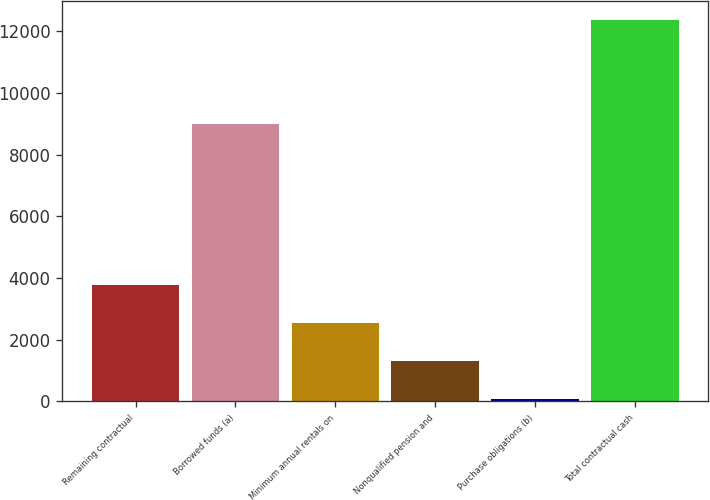Convert chart to OTSL. <chart><loc_0><loc_0><loc_500><loc_500><bar_chart><fcel>Remaining contractual<fcel>Borrowed funds (a)<fcel>Minimum annual rentals on<fcel>Nonqualified pension and<fcel>Purchase obligations (b)<fcel>Total contractual cash<nl><fcel>3761.3<fcel>9003<fcel>2530.2<fcel>1299.1<fcel>68<fcel>12379<nl></chart> 